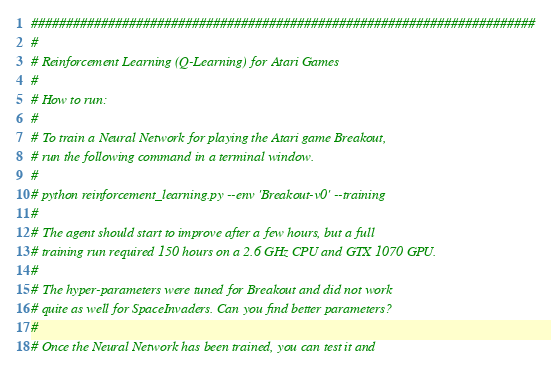<code> <loc_0><loc_0><loc_500><loc_500><_Python_>########################################################################
#
# Reinforcement Learning (Q-Learning) for Atari Games
#
# How to run:
#
# To train a Neural Network for playing the Atari game Breakout,
# run the following command in a terminal window.
#
# python reinforcement_learning.py --env 'Breakout-v0' --training
#
# The agent should start to improve after a few hours, but a full
# training run required 150 hours on a 2.6 GHz CPU and GTX 1070 GPU.
#
# The hyper-parameters were tuned for Breakout and did not work
# quite as well for SpaceInvaders. Can you find better parameters?
#
# Once the Neural Network has been trained, you can test it and</code> 